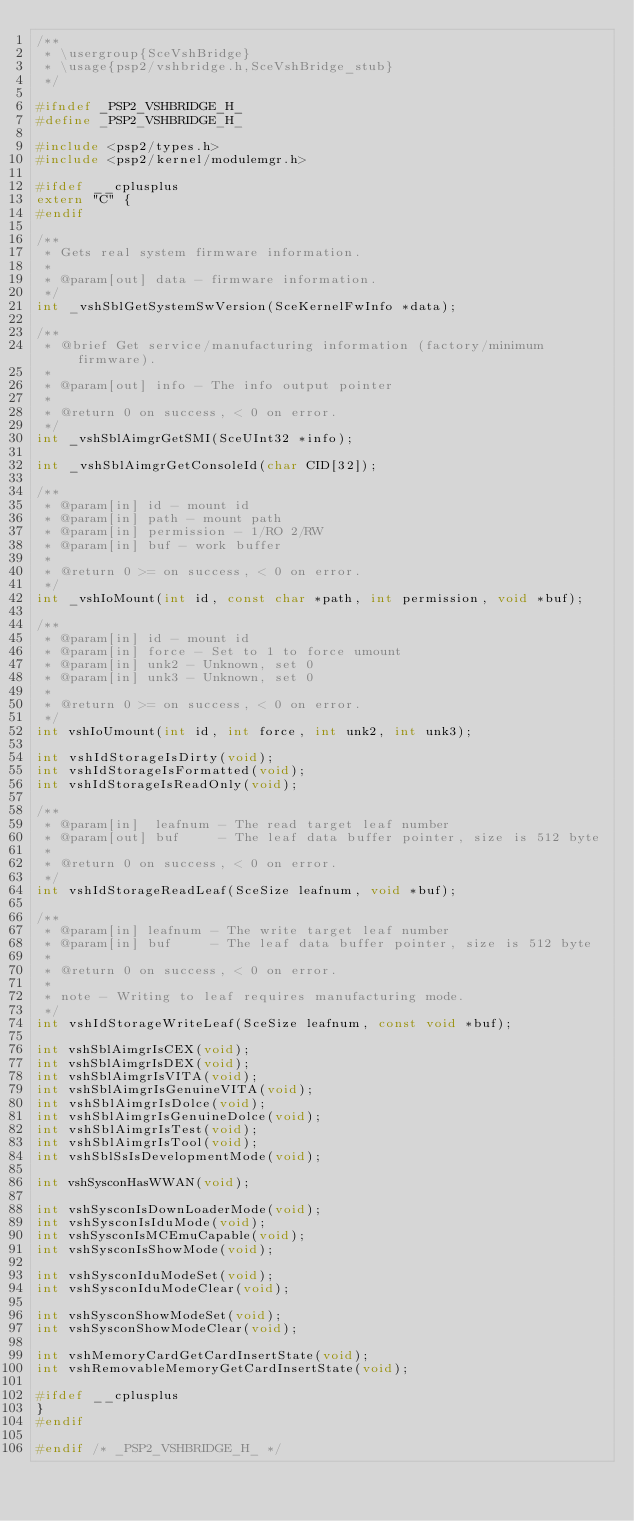<code> <loc_0><loc_0><loc_500><loc_500><_C_>/**
 * \usergroup{SceVshBridge}
 * \usage{psp2/vshbridge.h,SceVshBridge_stub}
 */

#ifndef _PSP2_VSHBRIDGE_H_
#define _PSP2_VSHBRIDGE_H_

#include <psp2/types.h>
#include <psp2/kernel/modulemgr.h>

#ifdef __cplusplus
extern "C" {
#endif

/**
 * Gets real system firmware information.
 *
 * @param[out] data - firmware information.
 */
int _vshSblGetSystemSwVersion(SceKernelFwInfo *data);

/**
 * @brief Get service/manufacturing information (factory/minimum firmware).
 *
 * @param[out] info - The info output pointer
 *
 * @return 0 on success, < 0 on error.
 */
int _vshSblAimgrGetSMI(SceUInt32 *info);

int _vshSblAimgrGetConsoleId(char CID[32]);

/**
 * @param[in] id - mount id
 * @param[in] path - mount path
 * @param[in] permission - 1/RO 2/RW
 * @param[in] buf - work buffer
 *
 * @return 0 >= on success, < 0 on error.
 */
int _vshIoMount(int id, const char *path, int permission, void *buf);

/**
 * @param[in] id - mount id
 * @param[in] force - Set to 1 to force umount
 * @param[in] unk2 - Unknown, set 0
 * @param[in] unk3 - Unknown, set 0
 *
 * @return 0 >= on success, < 0 on error.
 */
int vshIoUmount(int id, int force, int unk2, int unk3);

int vshIdStorageIsDirty(void);
int vshIdStorageIsFormatted(void);
int vshIdStorageIsReadOnly(void);

/**
 * @param[in]  leafnum - The read target leaf number
 * @param[out] buf     - The leaf data buffer pointer, size is 512 byte
 *
 * @return 0 on success, < 0 on error.
 */
int vshIdStorageReadLeaf(SceSize leafnum, void *buf);

/**
 * @param[in] leafnum - The write target leaf number
 * @param[in] buf     - The leaf data buffer pointer, size is 512 byte
 *
 * @return 0 on success, < 0 on error.
 *
 * note - Writing to leaf requires manufacturing mode.
 */
int vshIdStorageWriteLeaf(SceSize leafnum, const void *buf);

int vshSblAimgrIsCEX(void);
int vshSblAimgrIsDEX(void);
int vshSblAimgrIsVITA(void);
int vshSblAimgrIsGenuineVITA(void);
int vshSblAimgrIsDolce(void);
int vshSblAimgrIsGenuineDolce(void);
int vshSblAimgrIsTest(void);
int vshSblAimgrIsTool(void);
int vshSblSsIsDevelopmentMode(void);

int vshSysconHasWWAN(void);

int vshSysconIsDownLoaderMode(void);
int vshSysconIsIduMode(void);
int vshSysconIsMCEmuCapable(void);
int vshSysconIsShowMode(void);

int vshSysconIduModeSet(void);
int vshSysconIduModeClear(void);

int vshSysconShowModeSet(void);
int vshSysconShowModeClear(void);

int vshMemoryCardGetCardInsertState(void);
int vshRemovableMemoryGetCardInsertState(void);

#ifdef __cplusplus
}
#endif

#endif /* _PSP2_VSHBRIDGE_H_ */
</code> 